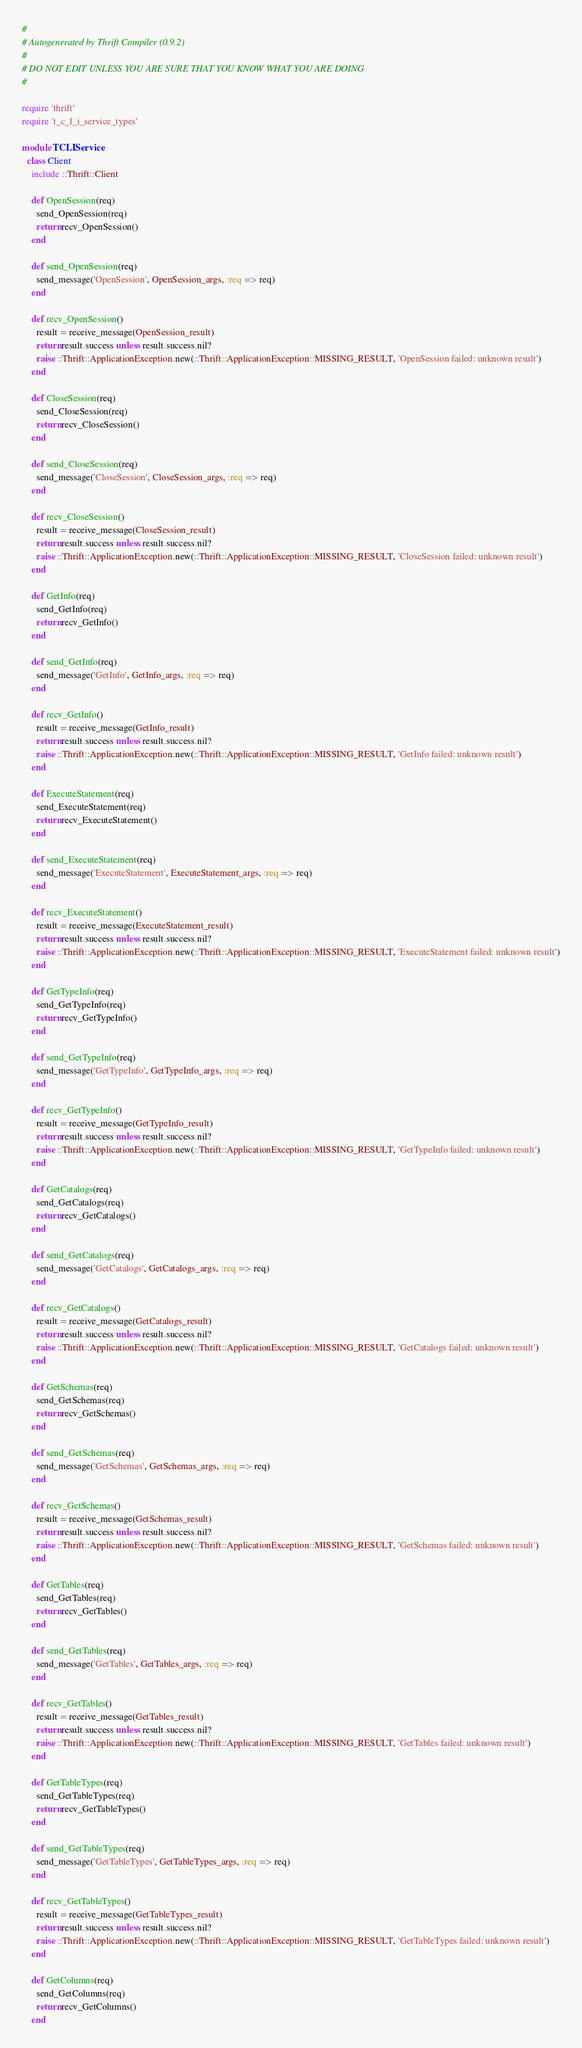Convert code to text. <code><loc_0><loc_0><loc_500><loc_500><_Ruby_>#
# Autogenerated by Thrift Compiler (0.9.2)
#
# DO NOT EDIT UNLESS YOU ARE SURE THAT YOU KNOW WHAT YOU ARE DOING
#

require 'thrift'
require 't_c_l_i_service_types'

module TCLIService
  class Client
    include ::Thrift::Client

    def OpenSession(req)
      send_OpenSession(req)
      return recv_OpenSession()
    end

    def send_OpenSession(req)
      send_message('OpenSession', OpenSession_args, :req => req)
    end

    def recv_OpenSession()
      result = receive_message(OpenSession_result)
      return result.success unless result.success.nil?
      raise ::Thrift::ApplicationException.new(::Thrift::ApplicationException::MISSING_RESULT, 'OpenSession failed: unknown result')
    end

    def CloseSession(req)
      send_CloseSession(req)
      return recv_CloseSession()
    end

    def send_CloseSession(req)
      send_message('CloseSession', CloseSession_args, :req => req)
    end

    def recv_CloseSession()
      result = receive_message(CloseSession_result)
      return result.success unless result.success.nil?
      raise ::Thrift::ApplicationException.new(::Thrift::ApplicationException::MISSING_RESULT, 'CloseSession failed: unknown result')
    end

    def GetInfo(req)
      send_GetInfo(req)
      return recv_GetInfo()
    end

    def send_GetInfo(req)
      send_message('GetInfo', GetInfo_args, :req => req)
    end

    def recv_GetInfo()
      result = receive_message(GetInfo_result)
      return result.success unless result.success.nil?
      raise ::Thrift::ApplicationException.new(::Thrift::ApplicationException::MISSING_RESULT, 'GetInfo failed: unknown result')
    end

    def ExecuteStatement(req)
      send_ExecuteStatement(req)
      return recv_ExecuteStatement()
    end

    def send_ExecuteStatement(req)
      send_message('ExecuteStatement', ExecuteStatement_args, :req => req)
    end

    def recv_ExecuteStatement()
      result = receive_message(ExecuteStatement_result)
      return result.success unless result.success.nil?
      raise ::Thrift::ApplicationException.new(::Thrift::ApplicationException::MISSING_RESULT, 'ExecuteStatement failed: unknown result')
    end

    def GetTypeInfo(req)
      send_GetTypeInfo(req)
      return recv_GetTypeInfo()
    end

    def send_GetTypeInfo(req)
      send_message('GetTypeInfo', GetTypeInfo_args, :req => req)
    end

    def recv_GetTypeInfo()
      result = receive_message(GetTypeInfo_result)
      return result.success unless result.success.nil?
      raise ::Thrift::ApplicationException.new(::Thrift::ApplicationException::MISSING_RESULT, 'GetTypeInfo failed: unknown result')
    end

    def GetCatalogs(req)
      send_GetCatalogs(req)
      return recv_GetCatalogs()
    end

    def send_GetCatalogs(req)
      send_message('GetCatalogs', GetCatalogs_args, :req => req)
    end

    def recv_GetCatalogs()
      result = receive_message(GetCatalogs_result)
      return result.success unless result.success.nil?
      raise ::Thrift::ApplicationException.new(::Thrift::ApplicationException::MISSING_RESULT, 'GetCatalogs failed: unknown result')
    end

    def GetSchemas(req)
      send_GetSchemas(req)
      return recv_GetSchemas()
    end

    def send_GetSchemas(req)
      send_message('GetSchemas', GetSchemas_args, :req => req)
    end

    def recv_GetSchemas()
      result = receive_message(GetSchemas_result)
      return result.success unless result.success.nil?
      raise ::Thrift::ApplicationException.new(::Thrift::ApplicationException::MISSING_RESULT, 'GetSchemas failed: unknown result')
    end

    def GetTables(req)
      send_GetTables(req)
      return recv_GetTables()
    end

    def send_GetTables(req)
      send_message('GetTables', GetTables_args, :req => req)
    end

    def recv_GetTables()
      result = receive_message(GetTables_result)
      return result.success unless result.success.nil?
      raise ::Thrift::ApplicationException.new(::Thrift::ApplicationException::MISSING_RESULT, 'GetTables failed: unknown result')
    end

    def GetTableTypes(req)
      send_GetTableTypes(req)
      return recv_GetTableTypes()
    end

    def send_GetTableTypes(req)
      send_message('GetTableTypes', GetTableTypes_args, :req => req)
    end

    def recv_GetTableTypes()
      result = receive_message(GetTableTypes_result)
      return result.success unless result.success.nil?
      raise ::Thrift::ApplicationException.new(::Thrift::ApplicationException::MISSING_RESULT, 'GetTableTypes failed: unknown result')
    end

    def GetColumns(req)
      send_GetColumns(req)
      return recv_GetColumns()
    end
</code> 